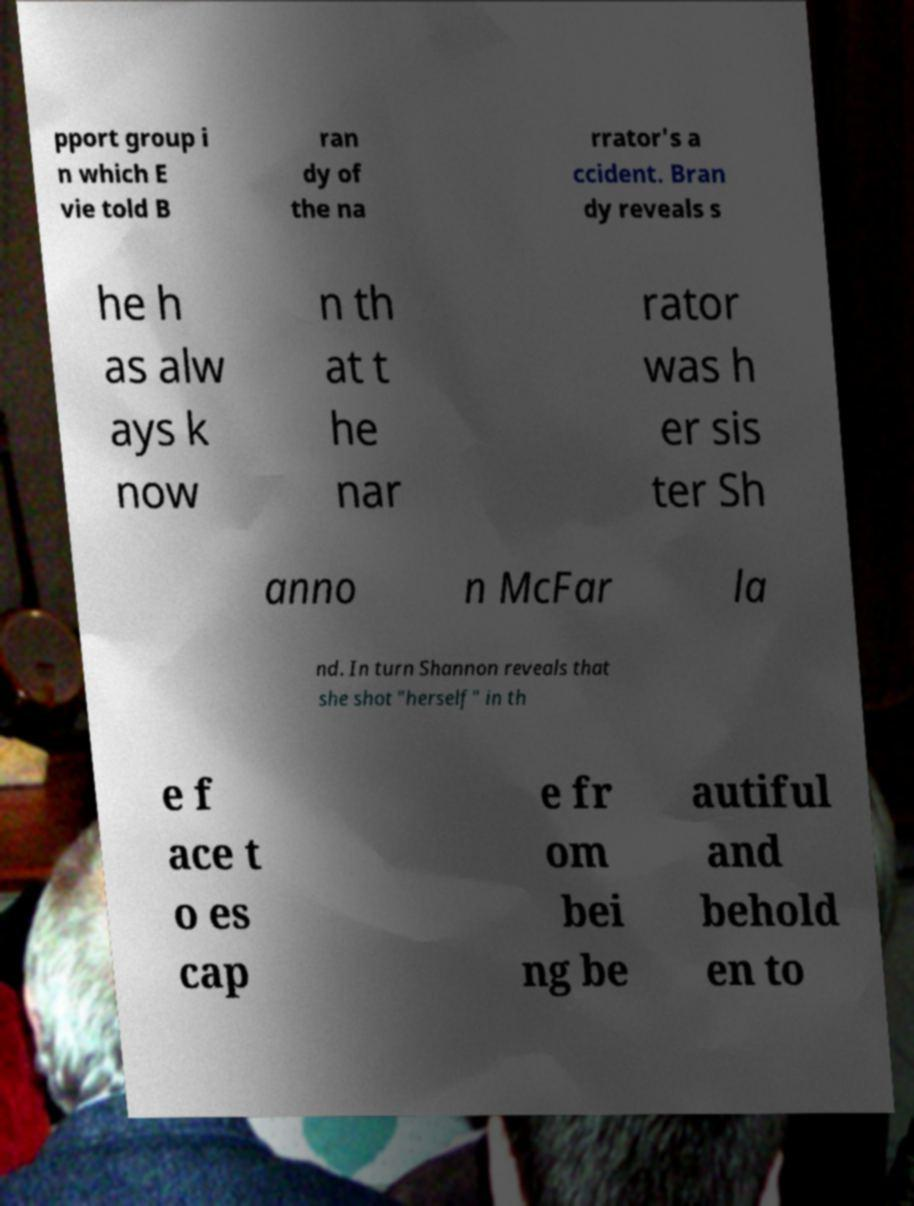Can you read and provide the text displayed in the image?This photo seems to have some interesting text. Can you extract and type it out for me? pport group i n which E vie told B ran dy of the na rrator's a ccident. Bran dy reveals s he h as alw ays k now n th at t he nar rator was h er sis ter Sh anno n McFar la nd. In turn Shannon reveals that she shot "herself" in th e f ace t o es cap e fr om bei ng be autiful and behold en to 